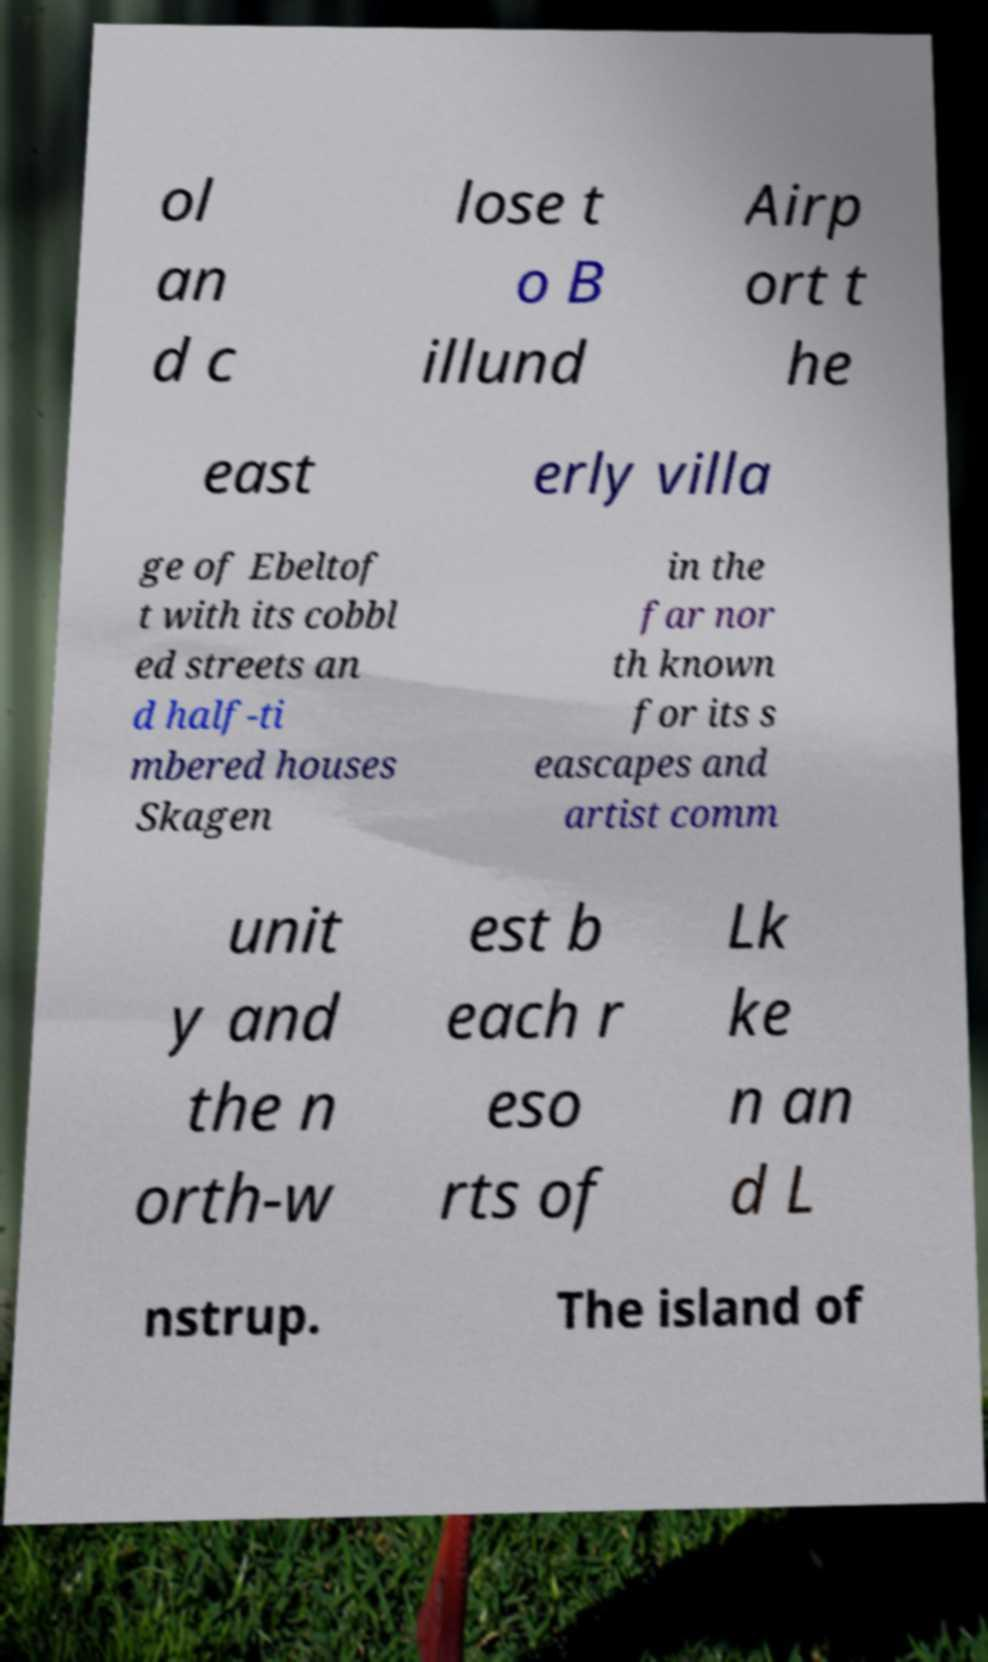Please identify and transcribe the text found in this image. ol an d c lose t o B illund Airp ort t he east erly villa ge of Ebeltof t with its cobbl ed streets an d half-ti mbered houses Skagen in the far nor th known for its s eascapes and artist comm unit y and the n orth-w est b each r eso rts of Lk ke n an d L nstrup. The island of 